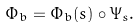Convert formula to latex. <formula><loc_0><loc_0><loc_500><loc_500>\Phi _ { b } = \Phi _ { b } ( s ) \circ \Psi _ { s } .</formula> 